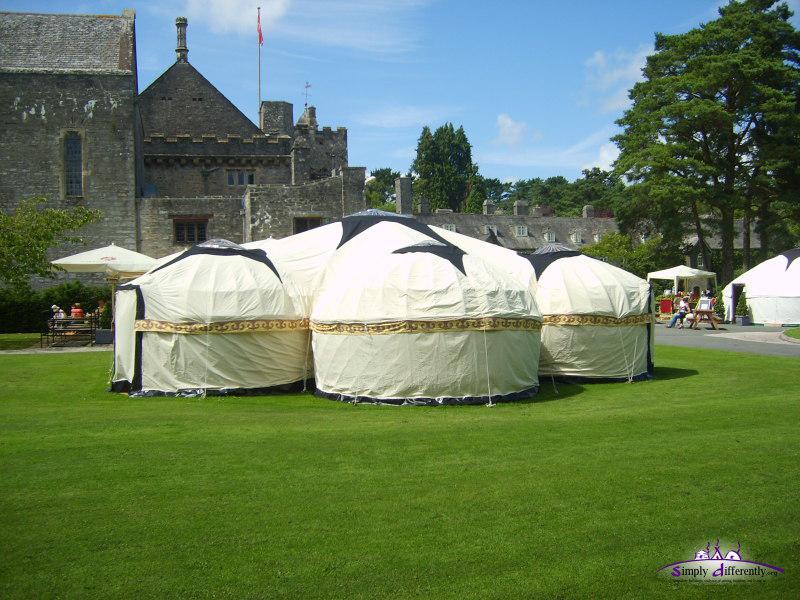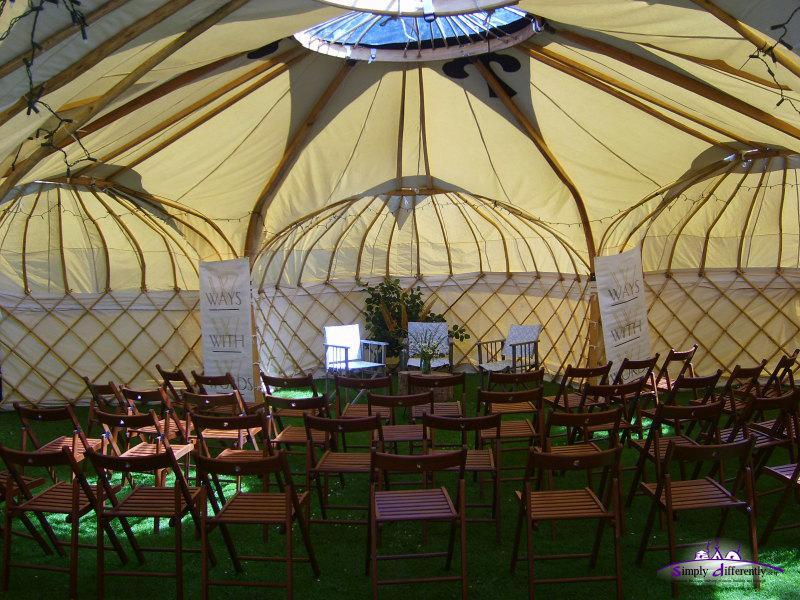The first image is the image on the left, the second image is the image on the right. Analyze the images presented: Is the assertion "Each image shows the exterior of one yurt, featuring some type of wood deck and railing." valid? Answer yes or no. No. The first image is the image on the left, the second image is the image on the right. Assess this claim about the two images: "Each image shows the front door of a single-story yurt with a roof that contrasts the walls, and a wooden decking entrance with railings.". Correct or not? Answer yes or no. No. 